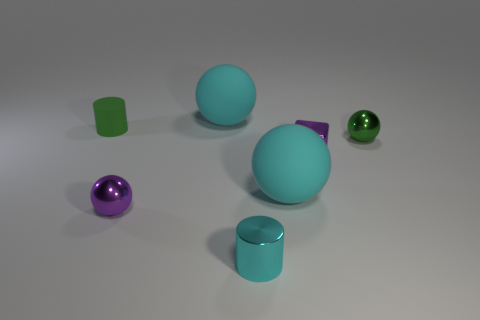What is the color of the small shiny sphere that is right of the cyan matte ball in front of the small purple shiny cube?
Offer a very short reply. Green. There is a small rubber thing that is the same shape as the tiny cyan metallic thing; what is its color?
Your response must be concise. Green. The other object that is the same shape as the tiny rubber thing is what size?
Your answer should be very brief. Small. There is a cyan sphere in front of the green cylinder; what is it made of?
Your answer should be very brief. Rubber. Are there fewer small purple cubes on the left side of the small purple cube than large cyan spheres?
Your answer should be very brief. Yes. There is a green object that is on the left side of the small ball that is left of the metallic cylinder; what shape is it?
Your answer should be very brief. Cylinder. What is the color of the small matte object?
Make the answer very short. Green. What number of other things are there of the same size as the purple block?
Keep it short and to the point. 4. There is a object that is behind the green metallic thing and right of the small green rubber cylinder; what material is it?
Give a very brief answer. Rubber. There is a cyan rubber thing that is behind the green metallic object; is it the same size as the green metallic sphere?
Your answer should be compact. No. 